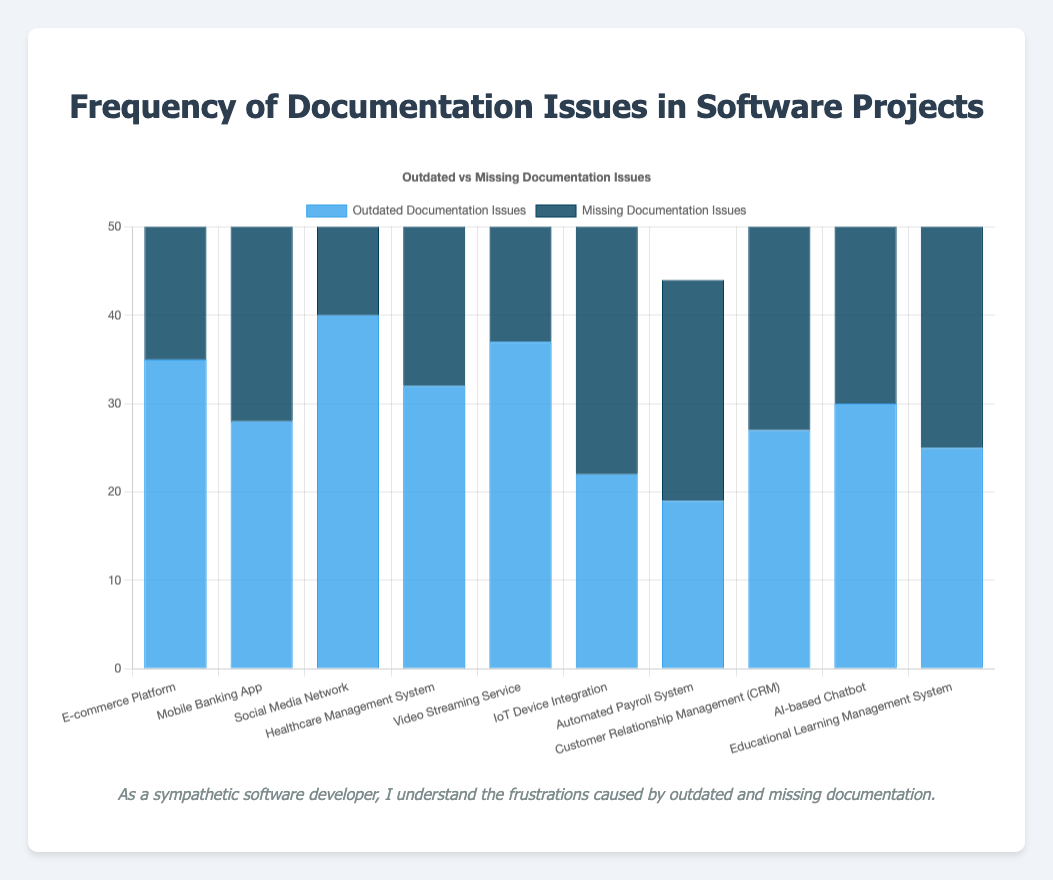Which project has the highest frequency of issues due to missing documentation? The Social Media Network project has the highest missing documentation issues with a value of 48.
Answer: Social Media Network Which project has fewer outdated documentation issues, the IoT Device Integration, or the Automated Payroll System? The IoT Device Integration has fewer outdated documentation issues (22) compared to the Automated Payroll System (19).
Answer: Automated Payroll System What is the combined total of issues due to outdated and missing documentation for the Healthcare Management System project? The combined total is 32 (outdated documentation issues) + 29 (missing documentation issues) = 61.
Answer: 61 By how much do the missing documentation issues for the Video Streaming Service exceed the outdated documentation issues? The missing documentation issues for the Video Streaming Service exceed the outdated documentation issues by 41 - 37 = 4.
Answer: 4 Which project has the highest frequency of issues due to outdated documentation? The Social Media Network project has the highest frequency of issues due to outdated documentation with a value of 40.
Answer: Social Media Network Compare the frequency of outdated documentation issues between the E-commerce Platform and the Educational Learning Management System. Which project has more issues? The E-commerce Platform has more outdated documentation issues (35) compared to the Educational Learning Management System (25).
Answer: E-commerce Platform How many more issues are in the Mobile Banking App due to missing documentation compared to outdated documentation? There are 35 (missing) - 28 (outdated) = 7 more issues in the Mobile Banking App due to missing documentation.
Answer: 7 What's the difference between outdated and missing documentation issues for the AI-based Chatbot? The difference is 30 (outdated) - 28 (missing) = 2.
Answer: 2 Is the number of missing documentation issues for the Video Streaming Service greater or lesser than the average number of missing documentation issues across all projects? The average number of missing documentation issues is (42 + 35 + 48 + 29 + 41 + 31 + 25 + 33 + 28 + 38) / 10 = 35.2. The Video Streaming Service has 41, which is greater than 35.2.
Answer: Greater 